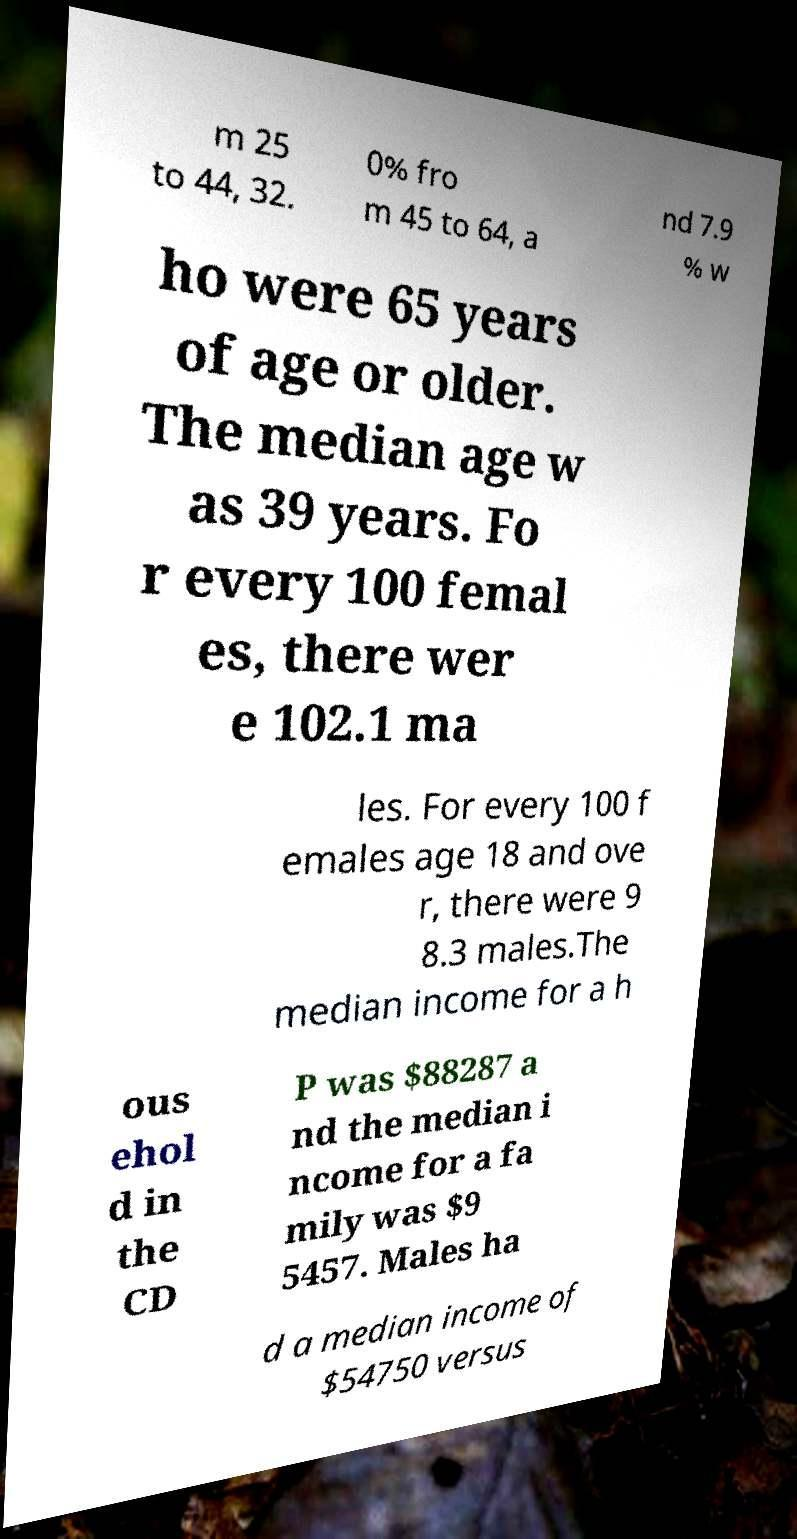What messages or text are displayed in this image? I need them in a readable, typed format. m 25 to 44, 32. 0% fro m 45 to 64, a nd 7.9 % w ho were 65 years of age or older. The median age w as 39 years. Fo r every 100 femal es, there wer e 102.1 ma les. For every 100 f emales age 18 and ove r, there were 9 8.3 males.The median income for a h ous ehol d in the CD P was $88287 a nd the median i ncome for a fa mily was $9 5457. Males ha d a median income of $54750 versus 